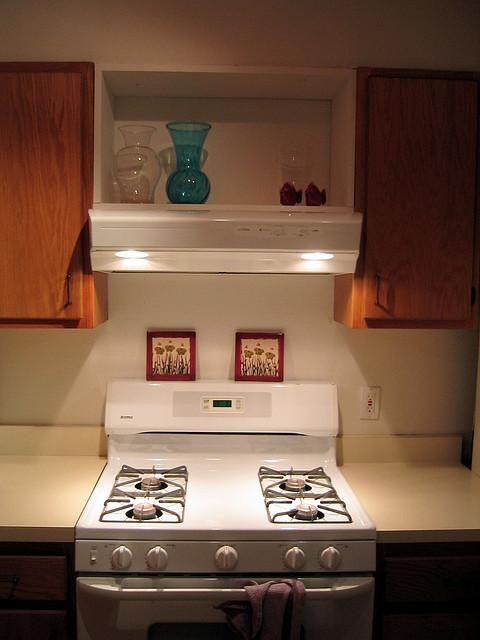What does the middle knob on the stove turn on?

Choices:
A) oven
B) right burners
C) timer
D) left burners oven 